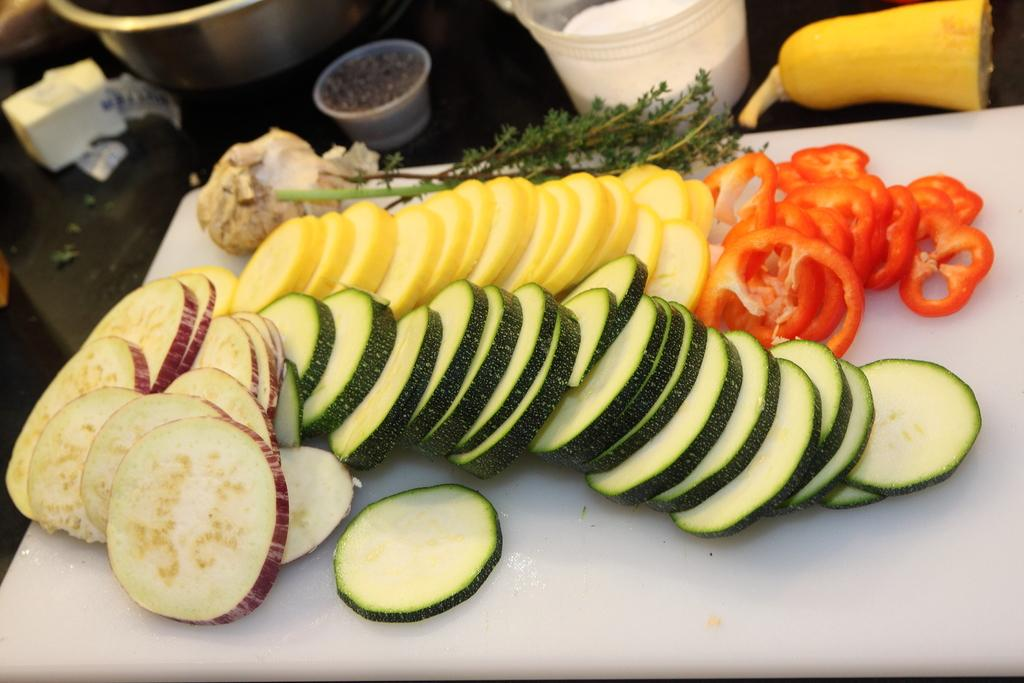What type of food items can be seen in the image? There are cut vegetables in the image. What type of containers are present in the image? There are cups, plastic bowls, and steel bowls visible in the image. Where are the objects located in the image? The objects are on a surface. Can you see a pig in the wilderness in the image? No, there is no pig or wilderness present in the image. 